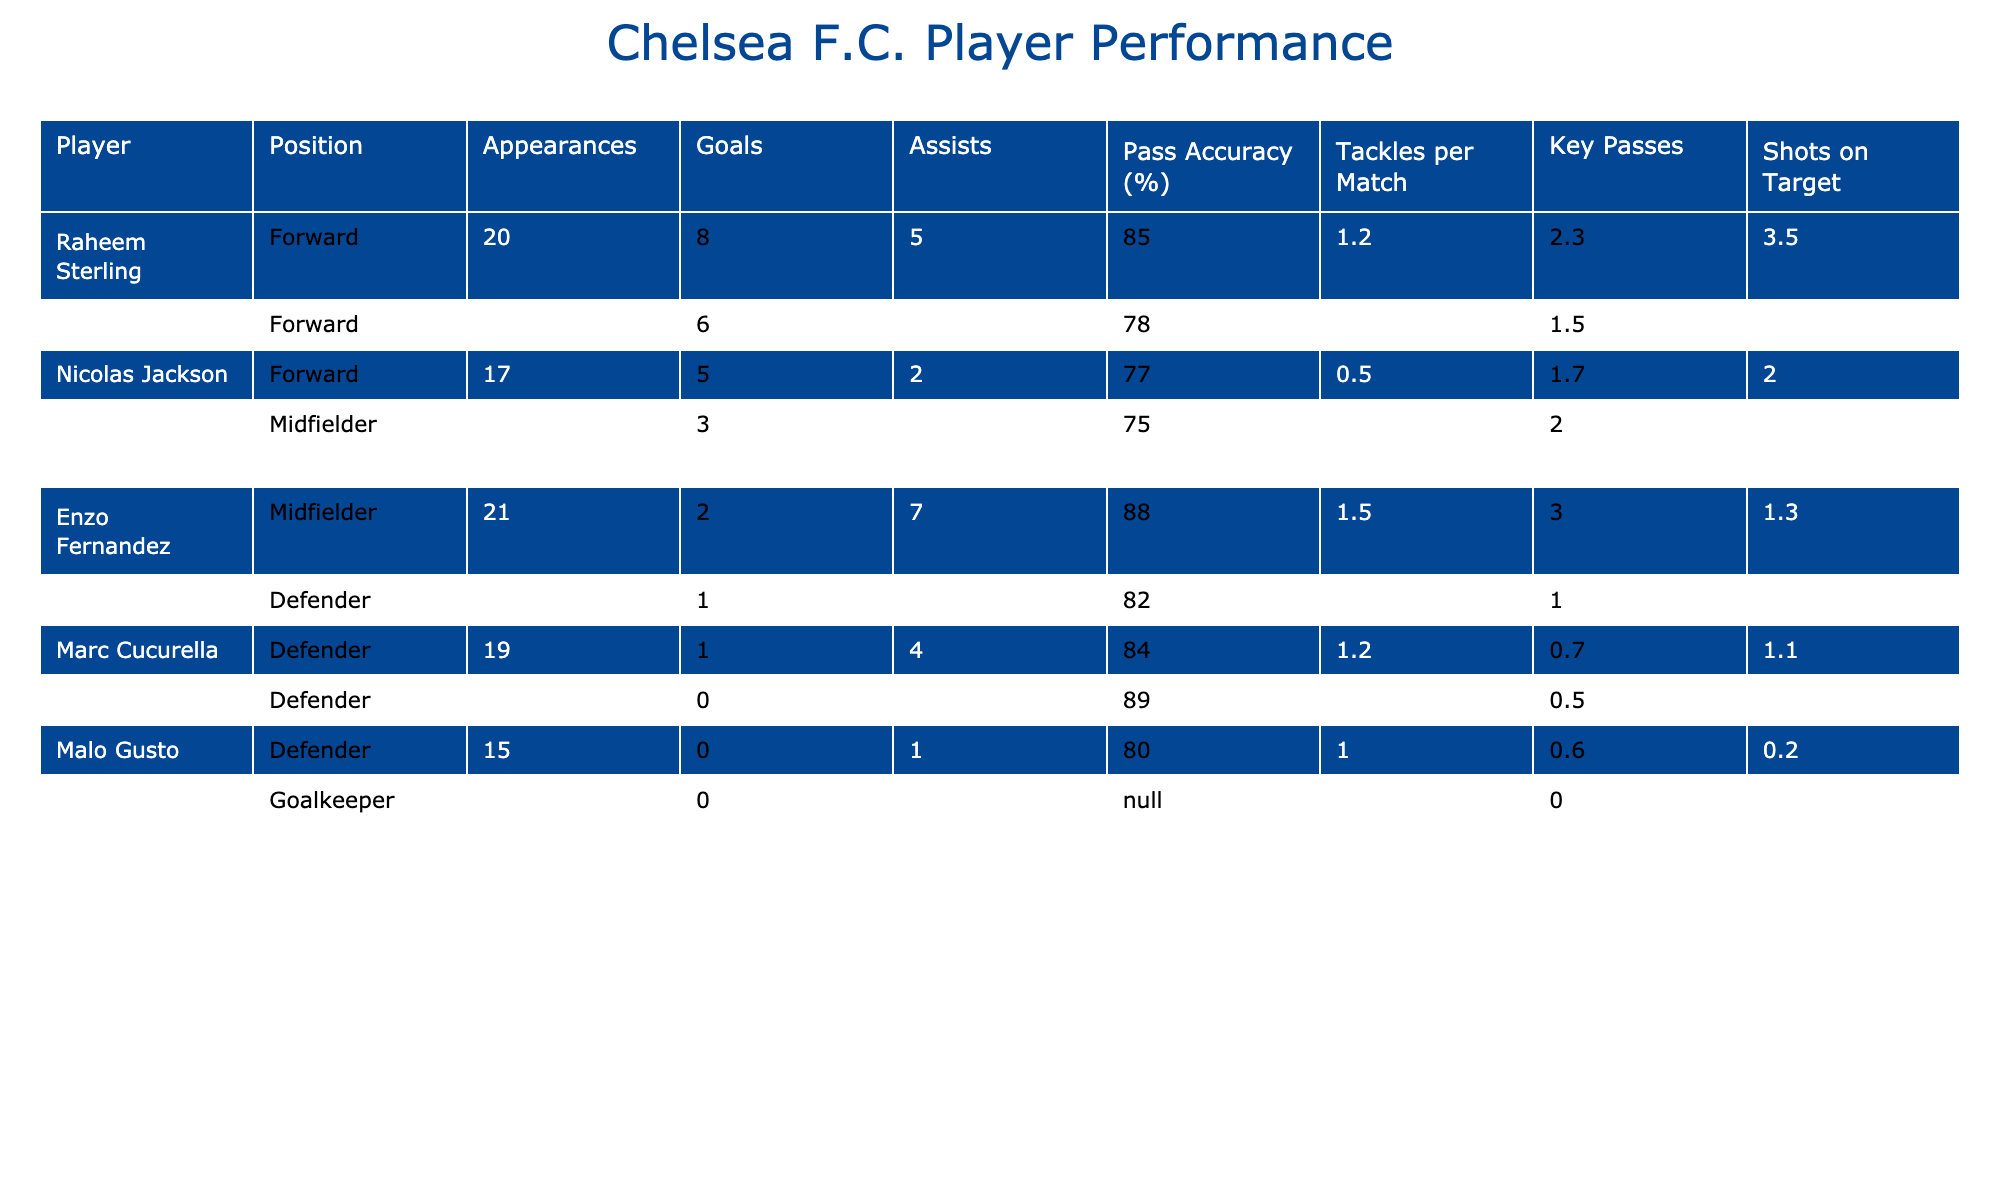What is the name of the player with the highest number of goals? The table lists all players along with their respective goals. By checking the "Goals" column, Raheem Sterling has the highest value with 8 goals.
Answer: Raheem Sterling How many assists did Enzo Fernandez record this season? Looking at the "Assists" column in the row for Enzo Fernandez, it shows that he has recorded 7 assists this season.
Answer: 7 Who has the best pass accuracy among the players? The "Pass Accuracy (%)" column needs to be inspected to find the value that is the highest. Enzo Fernandez has the best accuracy at 88%.
Answer: Enzo Fernandez What is the total number of goals scored by forwards in the squad? To find the total, we look at the "Goals" column for players identified as forwards: Raheem Sterling (8), Kai Havertz (6), and Nicolas Jackson (5). Adding these up: 8 + 6 + 5 = 19.
Answer: 19 Is it true that Kepa Arrizabalaga has scored a goal this season? By checking the "Goals" column for Kepa Arrizabalaga, it shows that the number of goals is 0. Therefore, the statement is false.
Answer: No Which defender has the most tackles per match? We must check the "Tackles per Match" column for each defender. Reece James records 2.0 tackles per match, which is the highest among defenders.
Answer: Reece James What is the average number of key passes made by midfielders on the team this season? The key passes for midfielders are: Enzo Fernandez (3.0) and Conor Gallagher (2.0). Adding them gives 5.0, and dividing by 2 (the number of midfielders) yields an average of 2.5 key passes.
Answer: 2.5 Which player has the lowest shots on target? Checking the "Shots on Target" column, we find that Malo Gusto has recorded only 0.2 shots on target, making him the player with the lowest value in this category.
Answer: Malo Gusto Did any of the defenders score more than one goal this season? The "Goals" column for defenders shows that both Reece James and Marc Cucurella scored 1, while Thiago Silva and Malo Gusto scored 0. Therefore, the answer is no, as no defender scored more than one goal.
Answer: No 